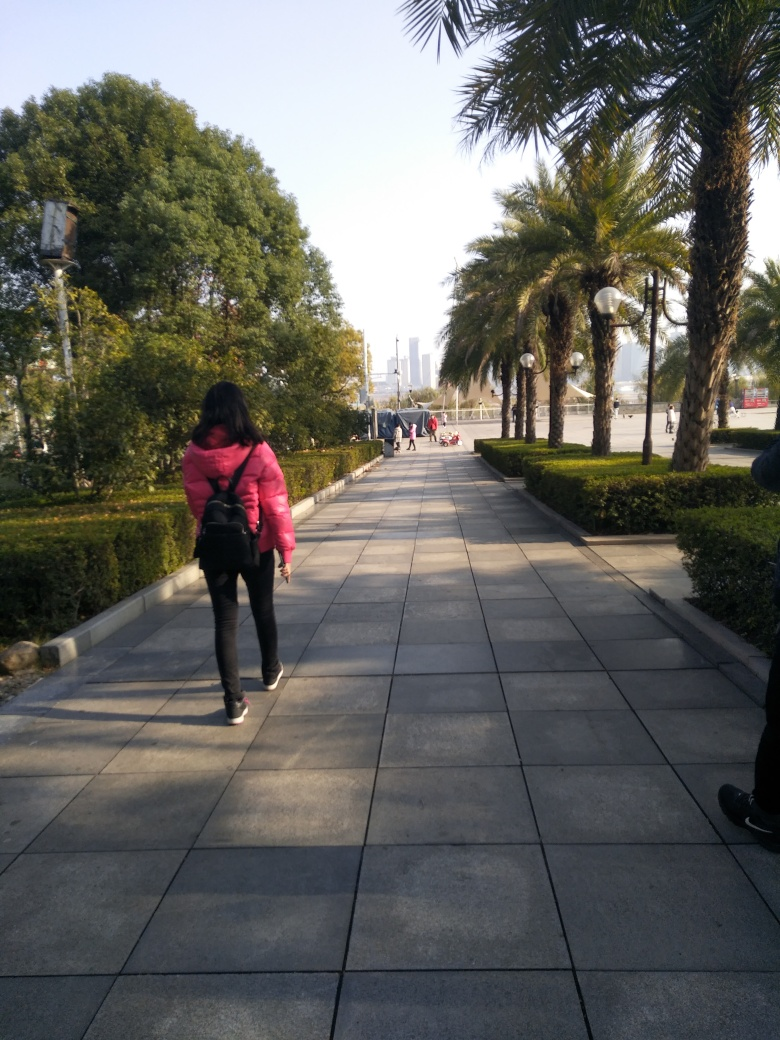Can you describe the current weather and time of day this photo seems to have been taken? The photo appears to have been taken on a clear day since the sky is visible and there don't seem to be many clouds. The shadows cast by the trees and people suggest it's during the daytime, possibly in the late morning or early afternoon, judging by the angle and length of the shadows. 